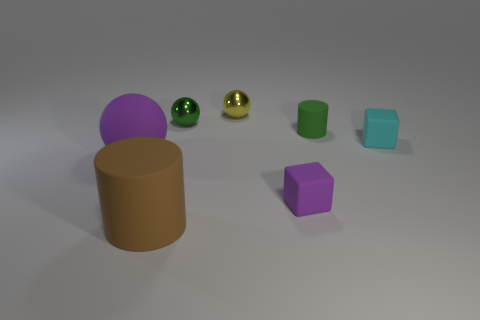Subtract all purple cylinders. Subtract all red blocks. How many cylinders are left? 2 Add 3 tiny blue metallic cylinders. How many objects exist? 10 Subtract all spheres. How many objects are left? 4 Add 1 large blue rubber balls. How many large blue rubber balls exist? 1 Subtract 1 yellow spheres. How many objects are left? 6 Subtract all large blue cylinders. Subtract all brown objects. How many objects are left? 6 Add 7 purple matte spheres. How many purple matte spheres are left? 8 